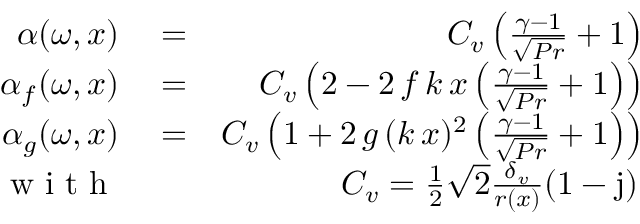<formula> <loc_0><loc_0><loc_500><loc_500>\begin{array} { r l r } { \alpha ( \omega , x ) } & = } & { C _ { v } \left ( \frac { \gamma - 1 } { \sqrt { P r } } + 1 \right ) } \\ { \alpha _ { f } ( \omega , x ) } & = } & { C _ { v } \left ( 2 - 2 \, f \, k \, x \left ( \frac { \gamma - 1 } { \sqrt { P r } } + 1 \right ) \right ) } \\ { \alpha _ { g } ( \omega , x ) } & = } & { C _ { v } \left ( 1 + 2 \, g \, ( k \, x ) ^ { 2 } \left ( \frac { \gamma - 1 } { \sqrt { P r } } + 1 \right ) \right ) } \\ { w i t h } & { C _ { v } = \frac { 1 } { 2 } \sqrt { 2 } \frac { \delta _ { v } } { r ( x ) } ( 1 - j ) \, } \end{array}</formula> 